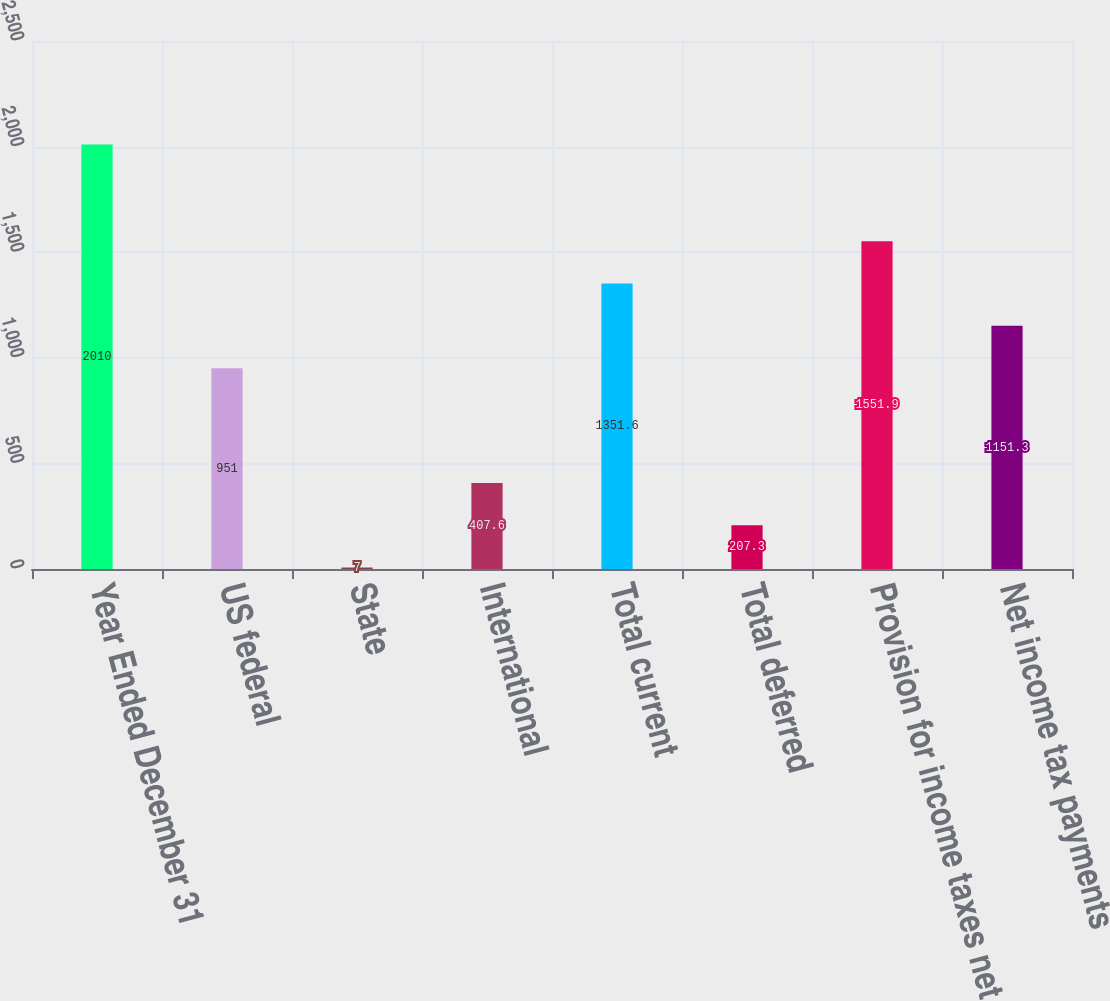<chart> <loc_0><loc_0><loc_500><loc_500><bar_chart><fcel>Year Ended December 31<fcel>US federal<fcel>State<fcel>International<fcel>Total current<fcel>Total deferred<fcel>Provision for income taxes net<fcel>Net income tax payments<nl><fcel>2010<fcel>951<fcel>7<fcel>407.6<fcel>1351.6<fcel>207.3<fcel>1551.9<fcel>1151.3<nl></chart> 